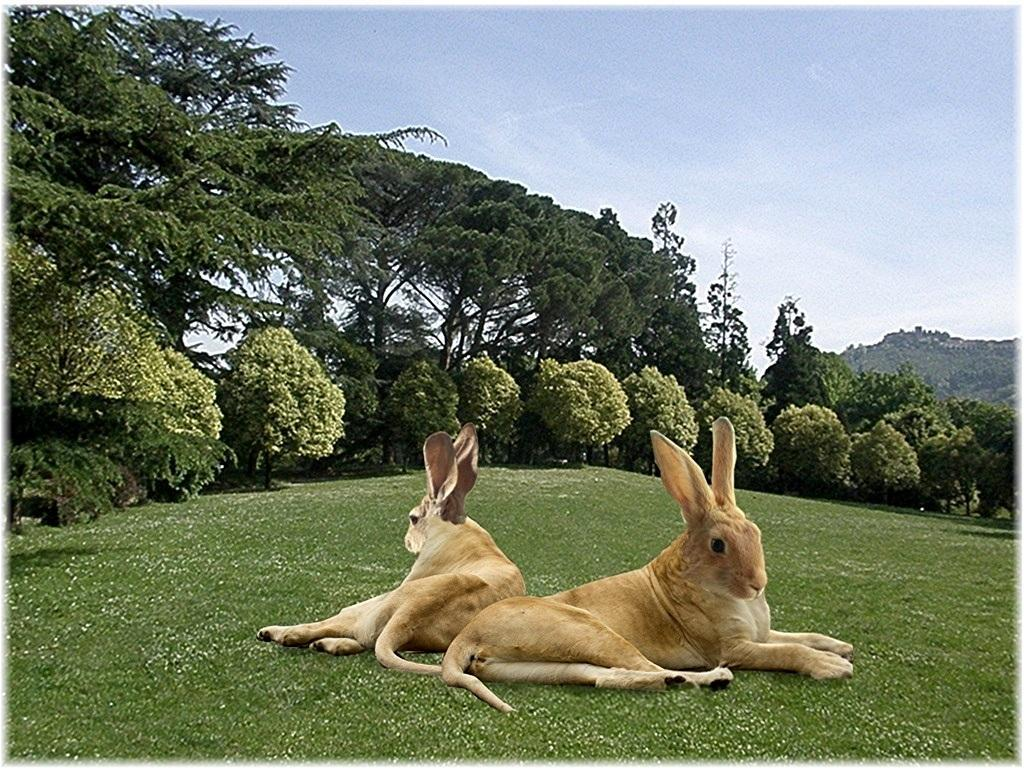What type of living organisms can be seen in the image? There are animals in the image. Where are the animals located? The animals are on the grass. What colors are the animals? The animals are in brown and cream color. What can be seen in the background of the image? There are trees, mountains, and the sky visible in the background of the image. What type of bead is being used by the animals to make a wish in the image? There is no bead or wish-making activity present in the image. 